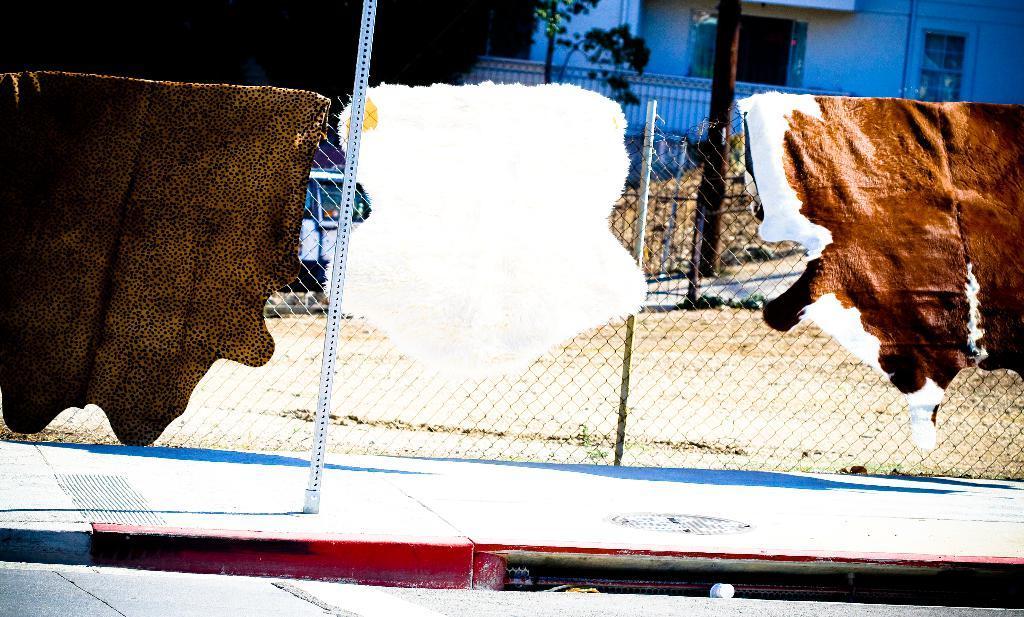Can you describe this image briefly? In this image there are animal skins hung on the fence and in the background there are building, trees and a vehicle. 